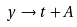<formula> <loc_0><loc_0><loc_500><loc_500>y \rightarrow t + A</formula> 